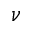Convert formula to latex. <formula><loc_0><loc_0><loc_500><loc_500>\nu</formula> 